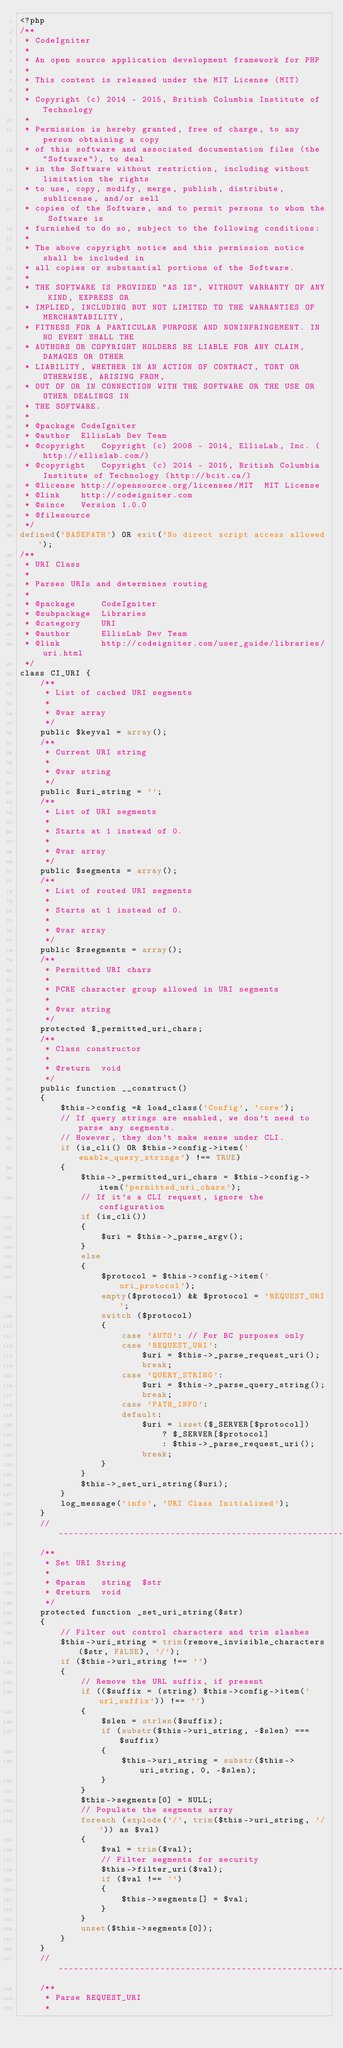Convert code to text. <code><loc_0><loc_0><loc_500><loc_500><_PHP_><?php
/**
 * CodeIgniter
 *
 * An open source application development framework for PHP
 *
 * This content is released under the MIT License (MIT)
 *
 * Copyright (c) 2014 - 2015, British Columbia Institute of Technology
 *
 * Permission is hereby granted, free of charge, to any person obtaining a copy
 * of this software and associated documentation files (the "Software"), to deal
 * in the Software without restriction, including without limitation the rights
 * to use, copy, modify, merge, publish, distribute, sublicense, and/or sell
 * copies of the Software, and to permit persons to whom the Software is
 * furnished to do so, subject to the following conditions:
 *
 * The above copyright notice and this permission notice shall be included in
 * all copies or substantial portions of the Software.
 *
 * THE SOFTWARE IS PROVIDED "AS IS", WITHOUT WARRANTY OF ANY KIND, EXPRESS OR
 * IMPLIED, INCLUDING BUT NOT LIMITED TO THE WARRANTIES OF MERCHANTABILITY,
 * FITNESS FOR A PARTICULAR PURPOSE AND NONINFRINGEMENT. IN NO EVENT SHALL THE
 * AUTHORS OR COPYRIGHT HOLDERS BE LIABLE FOR ANY CLAIM, DAMAGES OR OTHER
 * LIABILITY, WHETHER IN AN ACTION OF CONTRACT, TORT OR OTHERWISE, ARISING FROM,
 * OUT OF OR IN CONNECTION WITH THE SOFTWARE OR THE USE OR OTHER DEALINGS IN
 * THE SOFTWARE.
 *
 * @package	CodeIgniter
 * @author	EllisLab Dev Team
 * @copyright	Copyright (c) 2008 - 2014, EllisLab, Inc. (http://ellislab.com/)
 * @copyright	Copyright (c) 2014 - 2015, British Columbia Institute of Technology (http://bcit.ca/)
 * @license	http://opensource.org/licenses/MIT	MIT License
 * @link	http://codeigniter.com
 * @since	Version 1.0.0
 * @filesource
 */
defined('BASEPATH') OR exit('No direct script access allowed');
/**
 * URI Class
 *
 * Parses URIs and determines routing
 *
 * @package		CodeIgniter
 * @subpackage	Libraries
 * @category	URI
 * @author		EllisLab Dev Team
 * @link		http://codeigniter.com/user_guide/libraries/uri.html
 */
class CI_URI {
	/**
	 * List of cached URI segments
	 *
	 * @var	array
	 */
	public $keyval = array();
	/**
	 * Current URI string
	 *
	 * @var	string
	 */
	public $uri_string = '';
	/**
	 * List of URI segments
	 *
	 * Starts at 1 instead of 0.
	 *
	 * @var	array
	 */
	public $segments = array();
	/**
	 * List of routed URI segments
	 *
	 * Starts at 1 instead of 0.
	 *
	 * @var	array
	 */
	public $rsegments = array();
	/**
	 * Permitted URI chars
	 *
	 * PCRE character group allowed in URI segments
	 *
	 * @var	string
	 */
	protected $_permitted_uri_chars;
	/**
	 * Class constructor
	 *
	 * @return	void
	 */
	public function __construct()
	{
		$this->config =& load_class('Config', 'core');
		// If query strings are enabled, we don't need to parse any segments.
		// However, they don't make sense under CLI.
		if (is_cli() OR $this->config->item('enable_query_strings') !== TRUE)
		{
			$this->_permitted_uri_chars = $this->config->item('permitted_uri_chars');
			// If it's a CLI request, ignore the configuration
			if (is_cli())
			{
				$uri = $this->_parse_argv();
			}
			else
			{
				$protocol = $this->config->item('uri_protocol');
				empty($protocol) && $protocol = 'REQUEST_URI';
				switch ($protocol)
				{
					case 'AUTO': // For BC purposes only
					case 'REQUEST_URI':
						$uri = $this->_parse_request_uri();
						break;
					case 'QUERY_STRING':
						$uri = $this->_parse_query_string();
						break;
					case 'PATH_INFO':
					default:
						$uri = isset($_SERVER[$protocol])
							? $_SERVER[$protocol]
							: $this->_parse_request_uri();
						break;
				}
			}
			$this->_set_uri_string($uri);
		}
		log_message('info', 'URI Class Initialized');
	}
	// --------------------------------------------------------------------
	/**
	 * Set URI String
	 *
	 * @param 	string	$str
	 * @return	void
	 */
	protected function _set_uri_string($str)
	{
		// Filter out control characters and trim slashes
		$this->uri_string = trim(remove_invisible_characters($str, FALSE), '/');
		if ($this->uri_string !== '')
		{
			// Remove the URL suffix, if present
			if (($suffix = (string) $this->config->item('url_suffix')) !== '')
			{
				$slen = strlen($suffix);
				if (substr($this->uri_string, -$slen) === $suffix)
				{
					$this->uri_string = substr($this->uri_string, 0, -$slen);
				}
			}
			$this->segments[0] = NULL;
			// Populate the segments array
			foreach (explode('/', trim($this->uri_string, '/')) as $val)
			{
				$val = trim($val);
				// Filter segments for security
				$this->filter_uri($val);
				if ($val !== '')
				{
					$this->segments[] = $val;
				}
			}
			unset($this->segments[0]);
		}
	}
	// --------------------------------------------------------------------
	/**
	 * Parse REQUEST_URI
	 *</code> 